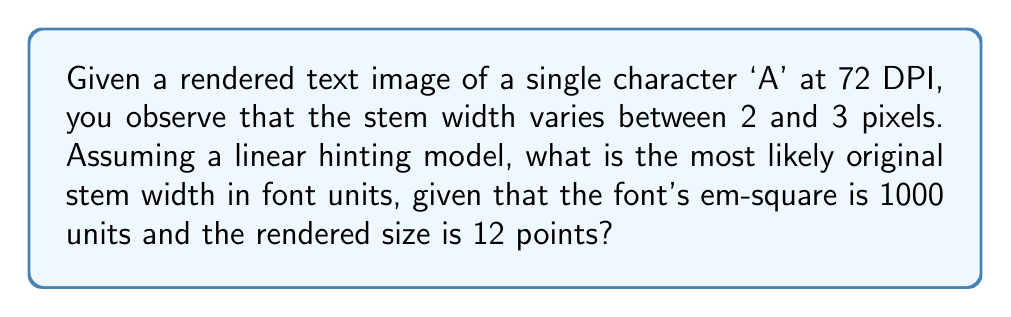Help me with this question. Let's approach this step-by-step:

1) First, we need to understand the relationship between font units, points, and pixels:
   - 1 point = 1/72 inch
   - At 72 DPI (dots per inch), 1 point = 1 pixel
   - The font's em-square is 1000 units
   - The rendered size is 12 points

2) Calculate how many font units correspond to one pixel:
   $$ \frac{1000 \text{ font units}}{12 \text{ points}} = \frac{1000}{12} \approx 83.33 \text{ font units/pixel} $$

3) The observed stem width varies between 2 and 3 pixels. Let's consider the average:
   $$ \text{Average observed width} = \frac{2 + 3}{2} = 2.5 \text{ pixels} $$

4) Convert the observed pixel width to font units:
   $$ 2.5 \text{ pixels} \times 83.33 \text{ font units/pixel} = 208.33 \text{ font units} $$

5) In font hinting, the goal is to align features to pixel boundaries. The variation between 2 and 3 pixels suggests that the original stem width was close to 2.5 pixels, and hinting adjusts it to either 2 or 3 pixels depending on its position.

6) Therefore, the most likely original stem width in font units would be close to our calculated value of 208.33 font units.

7) Since font units are typically integers, we round to the nearest whole number:
   $$ 208.33 \approx 208 \text{ font units} $$
Answer: 208 font units 